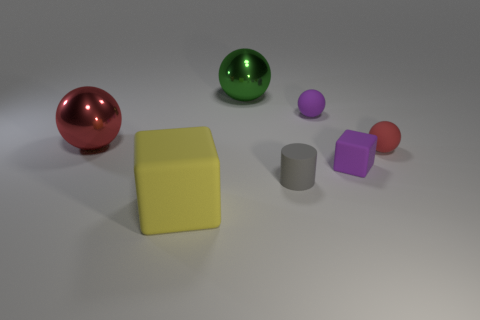How many other objects are there of the same color as the tiny matte cube?
Offer a terse response. 1. There is a ball that is the same color as the tiny rubber block; what size is it?
Ensure brevity in your answer.  Small. How many objects are either small things that are in front of the tiny purple rubber block or large balls that are on the right side of the yellow matte thing?
Give a very brief answer. 2. Is there a red metal ball of the same size as the purple cube?
Keep it short and to the point. No. There is another tiny object that is the same shape as the yellow matte object; what is its color?
Keep it short and to the point. Purple. There is a large sphere that is behind the big red metal sphere; are there any big yellow objects that are in front of it?
Provide a short and direct response. Yes. Is the shape of the large thing that is on the left side of the yellow cube the same as  the small red rubber thing?
Keep it short and to the point. Yes. What is the shape of the large green object?
Keep it short and to the point. Sphere. What number of objects are made of the same material as the purple ball?
Provide a short and direct response. 4. There is a large rubber block; is it the same color as the metallic sphere behind the big red ball?
Your answer should be very brief. No. 